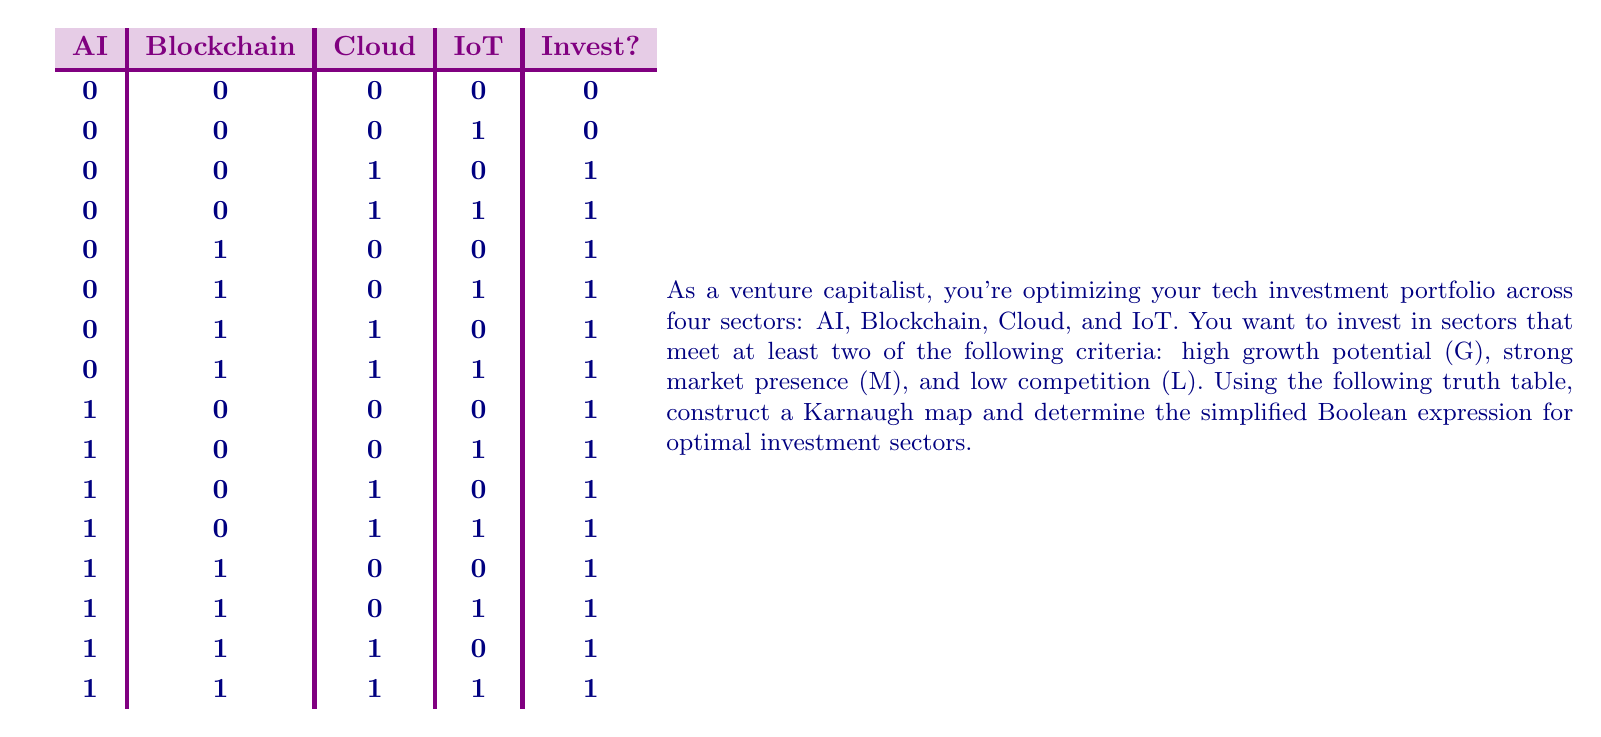What is the answer to this math problem? To solve this problem, we'll follow these steps:

1. Construct the Karnaugh map using the given truth table.
2. Identify the largest possible groups of 1s in the map.
3. Write the Boolean expression based on these groups.
4. Simplify the expression if possible.

Step 1: Construct the Karnaugh map

We'll use AI and Blockchain for the columns, and Cloud and IoT for the rows.

[asy]
unitsize(1cm);

draw((0,0)--(4,0)--(4,4)--(0,4)--cycle);
draw((0,1)--(4,1));
draw((0,2)--(4,2));
draw((0,3)--(4,3));
draw((1,0)--(1,4));
draw((2,0)--(2,4));
draw((3,0)--(3,4));

label("AI B", (0.5,4.5));
label("00", (0.5,4.2));
label("01", (1.5,4.2));
label("11", (2.5,4.2));
label("10", (3.5,4.2));

label("C I", (-0.5,2));
label("00", (-0.2,3.5));
label("01", (-0.2,2.5));
label("11", (-0.2,1.5));
label("10", (-0.2,0.5));

label("0", (0.5,3.5));
label("0", (0.5,2.5));
label("1", (0.5,1.5));
label("1", (0.5,0.5));

label("1", (1.5,3.5));
label("1", (1.5,2.5));
label("1", (1.5,1.5));
label("1", (1.5,0.5));

label("1", (2.5,3.5));
label("1", (2.5,2.5));
label("1", (2.5,1.5));
label("1", (2.5,0.5));

label("1", (3.5,3.5));
label("1", (3.5,2.5));
label("1", (3.5,1.5));
label("1", (3.5,0.5));
[/asy]

Step 2: Identify the largest possible groups of 1s

We can see that the entire map is filled with 1s except for two cells in the top-left corner.

Step 3: Write the Boolean expression

The simplified expression will be the complement of the group of 0s:

$F = \overline{(\overline{AI} \cdot \overline{B} \cdot \overline{C})}$

Step 4: Simplify the expression

Using De Morgan's law, we can simplify this to:

$F = AI + B + C$

This means we should invest if any of the following conditions are true:
- AI sector is viable (1)
- Blockchain sector is viable (1)
- Cloud sector is viable (1)

Note that the IoT sector doesn't appear in the final expression, indicating that its viability doesn't affect the investment decision in this scenario.
Answer: $AI + B + C$ 